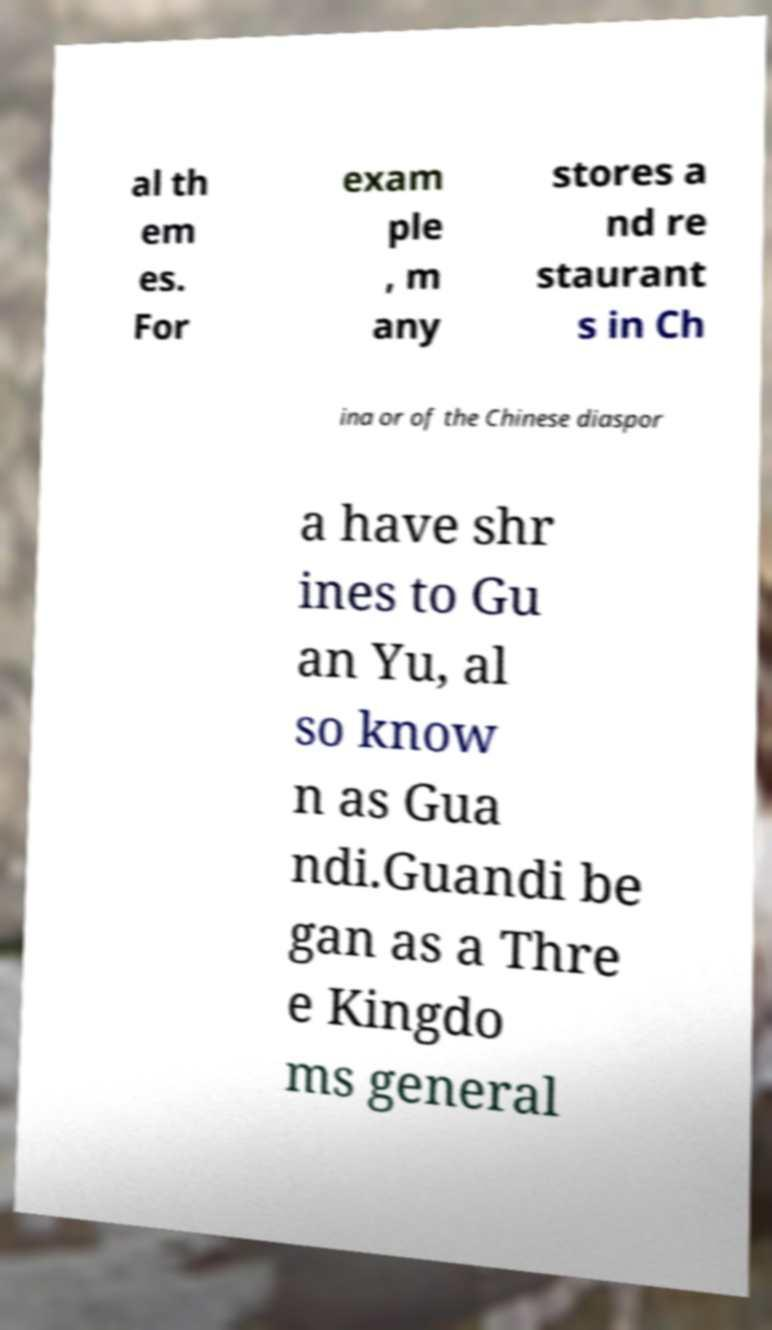Could you extract and type out the text from this image? al th em es. For exam ple , m any stores a nd re staurant s in Ch ina or of the Chinese diaspor a have shr ines to Gu an Yu, al so know n as Gua ndi.Guandi be gan as a Thre e Kingdo ms general 